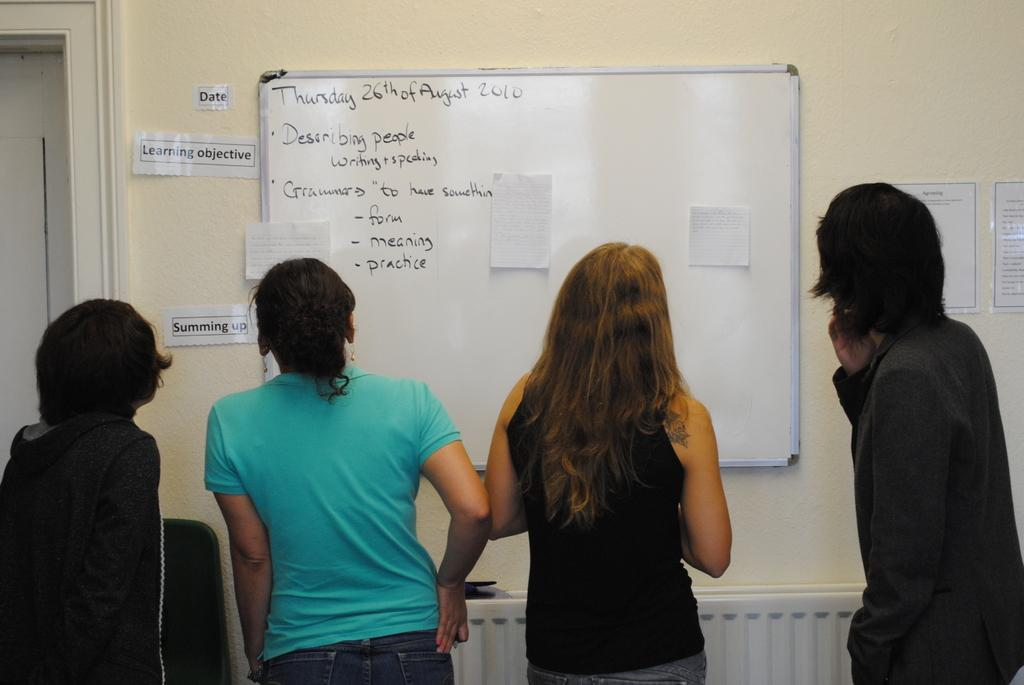<image>
Relay a brief, clear account of the picture shown. People look at a whiteboard labeled Thursday 26th of August. 